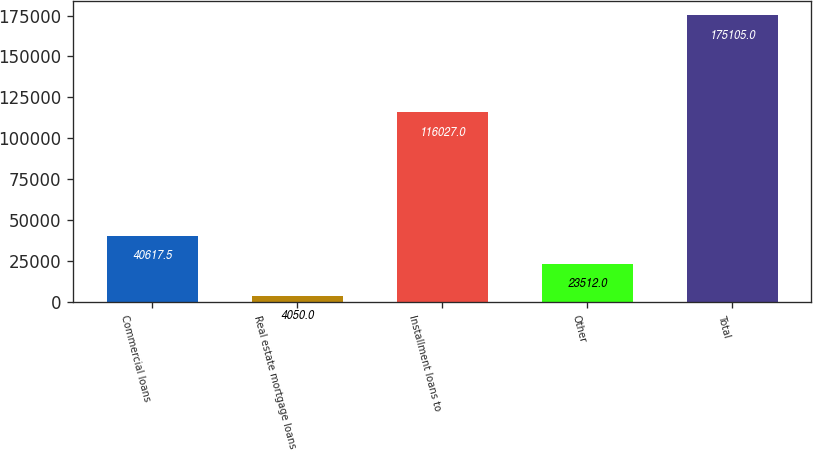Convert chart. <chart><loc_0><loc_0><loc_500><loc_500><bar_chart><fcel>Commercial loans<fcel>Real estate mortgage loans<fcel>Installment loans to<fcel>Other<fcel>Total<nl><fcel>40617.5<fcel>4050<fcel>116027<fcel>23512<fcel>175105<nl></chart> 